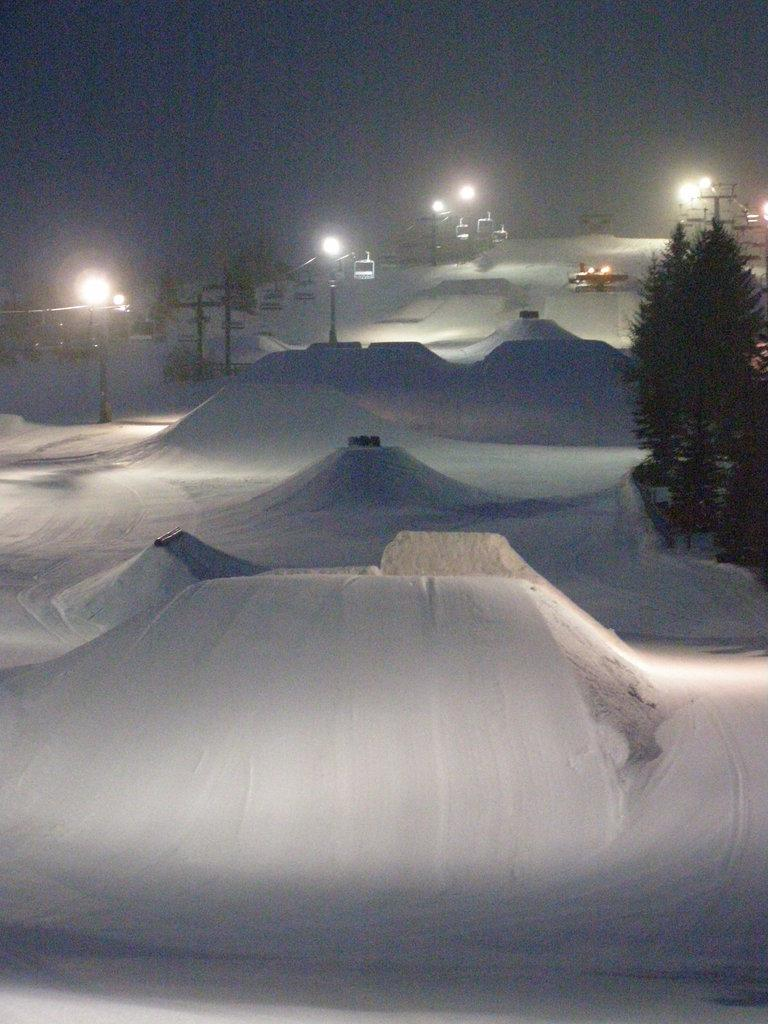What type of vegetation can be seen in the image? There are trees in the image. What is the weather like in the image? There is snow in the image, indicating a cold or wintery environment. What structures are present in the image? There are light poles and lift chairs in the image. What else can be seen in the image besides the trees, snow, light poles, and lift chairs? There are some unspecified objects in the image. What is visible in the background of the image? The sky is visible in the background of the image. What shape is the value of the discussion taking in the image? There is no discussion or value present in the image; it features trees, snow, light poles, lift chairs, and unspecified objects. 